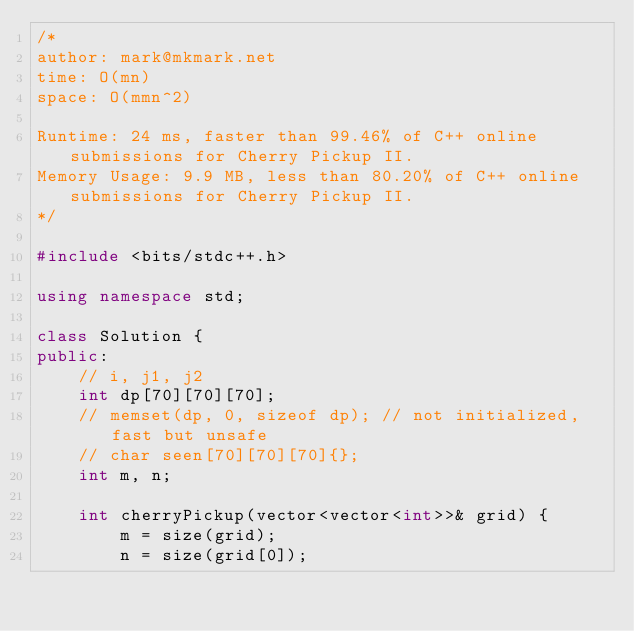<code> <loc_0><loc_0><loc_500><loc_500><_C++_>/*
author: mark@mkmark.net
time: O(mn)
space: O(mmn^2)

Runtime: 24 ms, faster than 99.46% of C++ online submissions for Cherry Pickup II.
Memory Usage: 9.9 MB, less than 80.20% of C++ online submissions for Cherry Pickup II.
*/

#include <bits/stdc++.h>

using namespace std;

class Solution {
public:
    // i, j1, j2
    int dp[70][70][70];
    // memset(dp, 0, sizeof dp); // not initialized, fast but unsafe
    // char seen[70][70][70]{};
    int m, n;

    int cherryPickup(vector<vector<int>>& grid) {
        m = size(grid);
        n = size(grid[0]);
</code> 